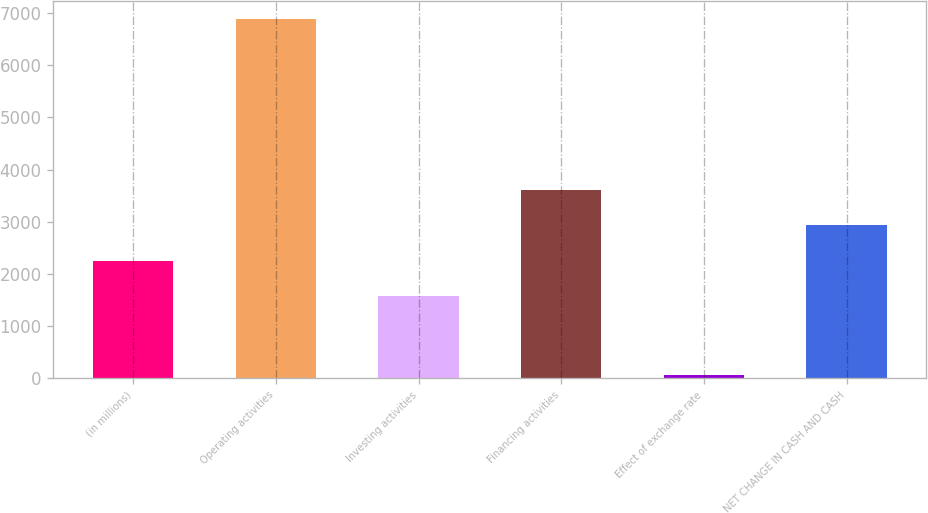Convert chart to OTSL. <chart><loc_0><loc_0><loc_500><loc_500><bar_chart><fcel>(in millions)<fcel>Operating activities<fcel>Investing activities<fcel>Financing activities<fcel>Effect of exchange rate<fcel>NET CHANGE IN CASH AND CASH<nl><fcel>2252.5<fcel>6880<fcel>1571<fcel>3615.5<fcel>65<fcel>2934<nl></chart> 